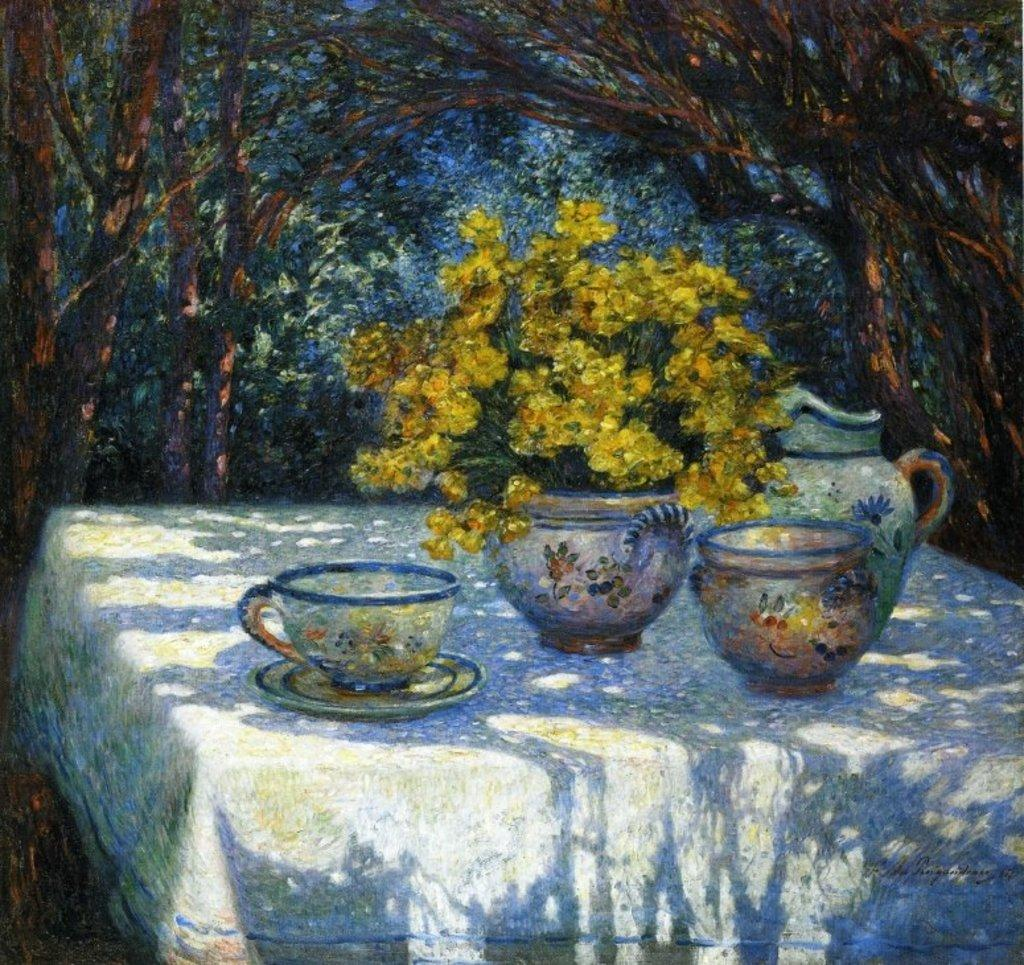What is depicted in the painting in the image? There is a painting of a flower vase in the image. What other objects can be seen in the image besides the painting? There are jugs, a cup, and a saucer visible in the image. Where are these objects located? The objects are on a table in the image. What can be seen in the background of the image? Trees are visible in the image. Can you tell me how many beams are supporting the lake in the image? There is no lake or beams present in the image; it features a painting of a flower vase and other objects on a table. 